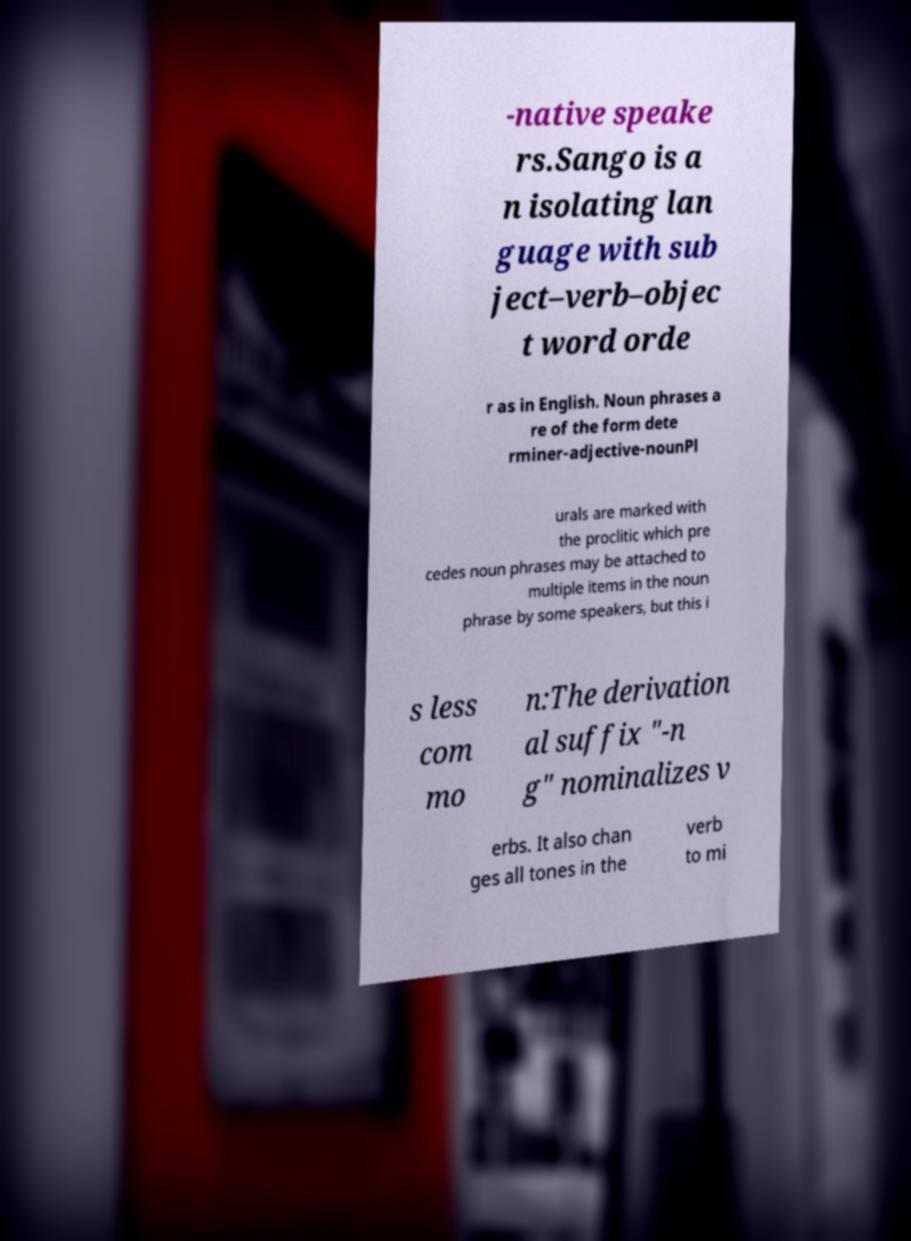There's text embedded in this image that I need extracted. Can you transcribe it verbatim? -native speake rs.Sango is a n isolating lan guage with sub ject–verb–objec t word orde r as in English. Noun phrases a re of the form dete rminer-adjective-nounPl urals are marked with the proclitic which pre cedes noun phrases may be attached to multiple items in the noun phrase by some speakers, but this i s less com mo n:The derivation al suffix "-n g" nominalizes v erbs. It also chan ges all tones in the verb to mi 